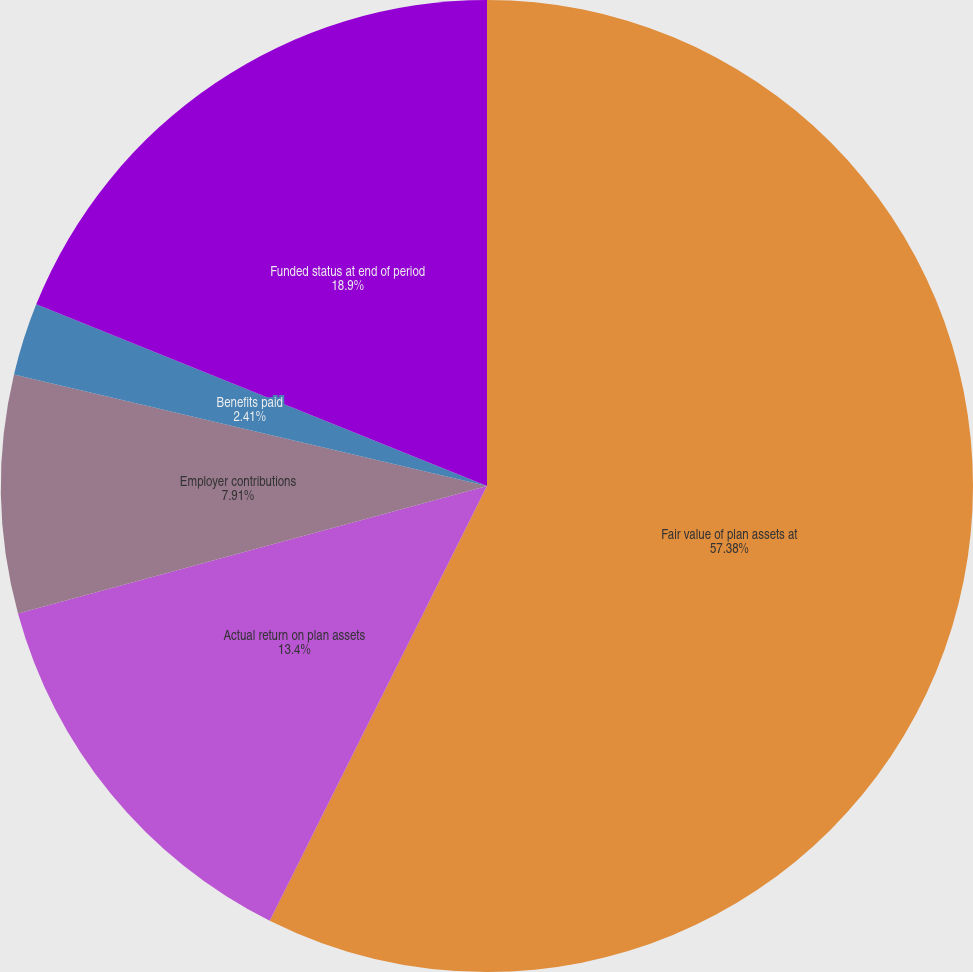Convert chart. <chart><loc_0><loc_0><loc_500><loc_500><pie_chart><fcel>Fair value of plan assets at<fcel>Actual return on plan assets<fcel>Employer contributions<fcel>Benefits paid<fcel>Funded status at end of period<nl><fcel>57.37%<fcel>13.4%<fcel>7.91%<fcel>2.41%<fcel>18.9%<nl></chart> 